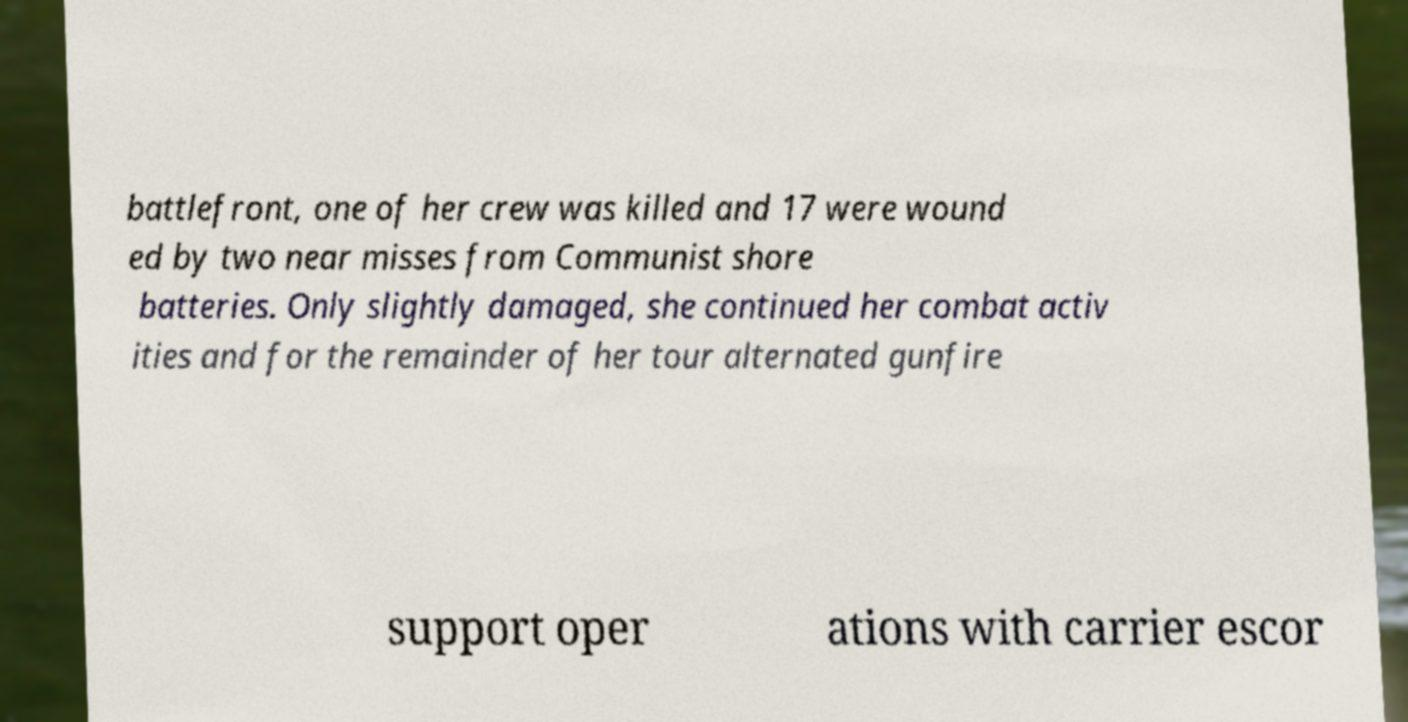I need the written content from this picture converted into text. Can you do that? battlefront, one of her crew was killed and 17 were wound ed by two near misses from Communist shore batteries. Only slightly damaged, she continued her combat activ ities and for the remainder of her tour alternated gunfire support oper ations with carrier escor 